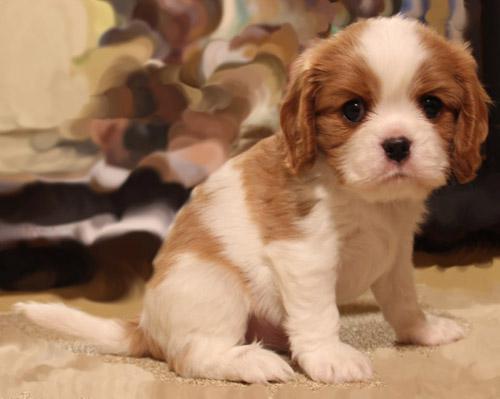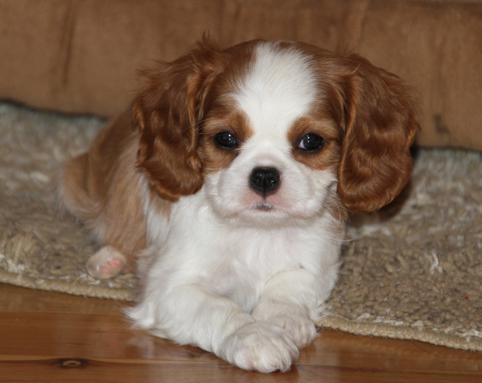The first image is the image on the left, the second image is the image on the right. Examine the images to the left and right. Is the description "A brown-and-white spaniel puppy is held in a human hand outdoors." accurate? Answer yes or no. No. The first image is the image on the left, the second image is the image on the right. For the images displayed, is the sentence "At least one of the puppies is indoors." factually correct? Answer yes or no. Yes. 